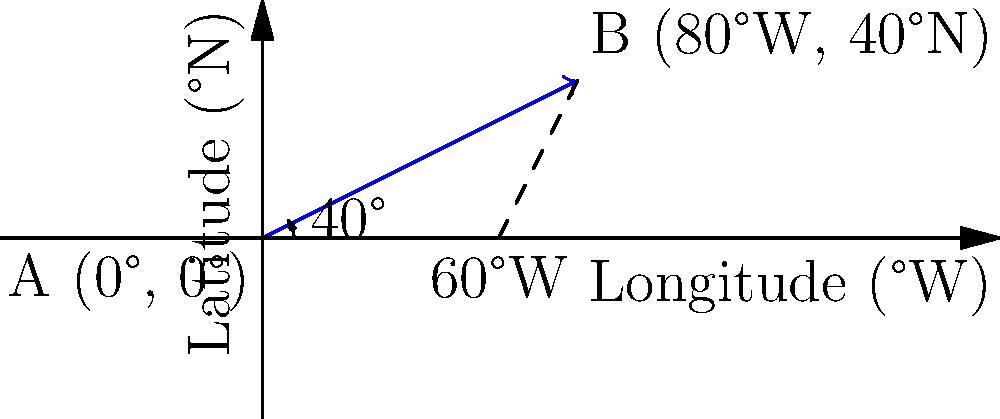A historical ship's journey across the Atlantic Ocean is represented by the blue vector in the diagram. The ship travels from point A (0°, 0°) to point B (80°W, 40°N). What is the magnitude of the velocity vector if the ship completes this journey in 20 days? To find the magnitude of the velocity vector, we need to follow these steps:

1. Calculate the distance traveled:
   We can use the Pythagorean theorem to find the distance.
   
   $\text{Distance} = \sqrt{(\text{change in longitude})^2 + (\text{change in latitude})^2}$
   $= \sqrt{80^2 + 40^2} = \sqrt{8000} \approx 89.44°$

2. Convert degrees to kilometers:
   1° of arc length on Earth's surface is approximately 111.12 km.
   
   $\text{Distance in km} = 89.44° \times 111.12 \text{ km/°} \approx 9938.17 \text{ km}$

3. Calculate the velocity:
   $\text{Velocity} = \frac{\text{Distance}}{\text{Time}}$
   $= \frac{9938.17 \text{ km}}{20 \text{ days}} \approx 496.91 \text{ km/day}$

Therefore, the magnitude of the velocity vector is approximately 496.91 km/day.
Answer: 496.91 km/day 